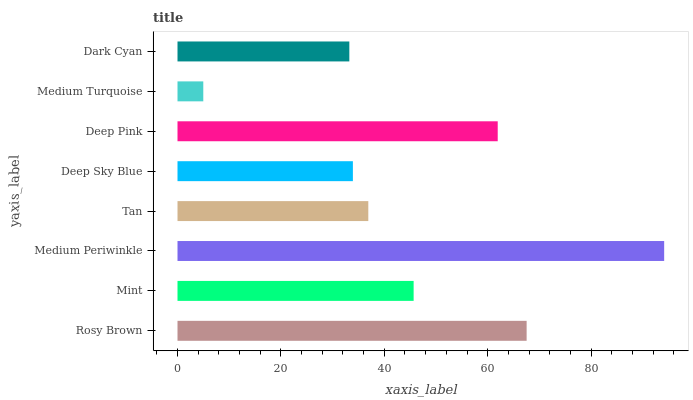Is Medium Turquoise the minimum?
Answer yes or no. Yes. Is Medium Periwinkle the maximum?
Answer yes or no. Yes. Is Mint the minimum?
Answer yes or no. No. Is Mint the maximum?
Answer yes or no. No. Is Rosy Brown greater than Mint?
Answer yes or no. Yes. Is Mint less than Rosy Brown?
Answer yes or no. Yes. Is Mint greater than Rosy Brown?
Answer yes or no. No. Is Rosy Brown less than Mint?
Answer yes or no. No. Is Mint the high median?
Answer yes or no. Yes. Is Tan the low median?
Answer yes or no. Yes. Is Rosy Brown the high median?
Answer yes or no. No. Is Deep Pink the low median?
Answer yes or no. No. 